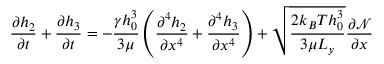<formula> <loc_0><loc_0><loc_500><loc_500>\frac { \partial h _ { 2 } } { \partial t } + \frac { \partial h _ { 3 } } { \partial t } = - \frac { \gamma h _ { 0 } ^ { 3 } } { 3 \mu } \left ( \frac { \partial ^ { 4 } h _ { 2 } } { \partial x ^ { 4 } } + \frac { \partial ^ { 4 } h _ { 3 } } { \partial x ^ { 4 } } \right ) + \sqrt { \frac { 2 k _ { B } T h _ { 0 } ^ { 3 } } { 3 \mu L _ { y } } } \frac { \partial \mathcal { N } } { \partial x }</formula> 